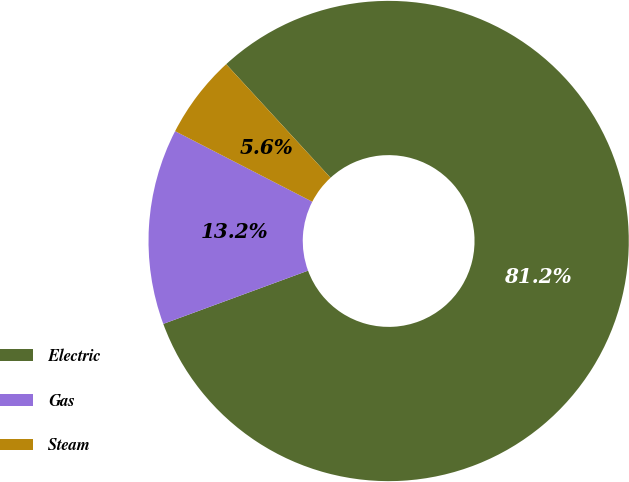Convert chart to OTSL. <chart><loc_0><loc_0><loc_500><loc_500><pie_chart><fcel>Electric<fcel>Gas<fcel>Steam<nl><fcel>81.22%<fcel>13.17%<fcel>5.61%<nl></chart> 